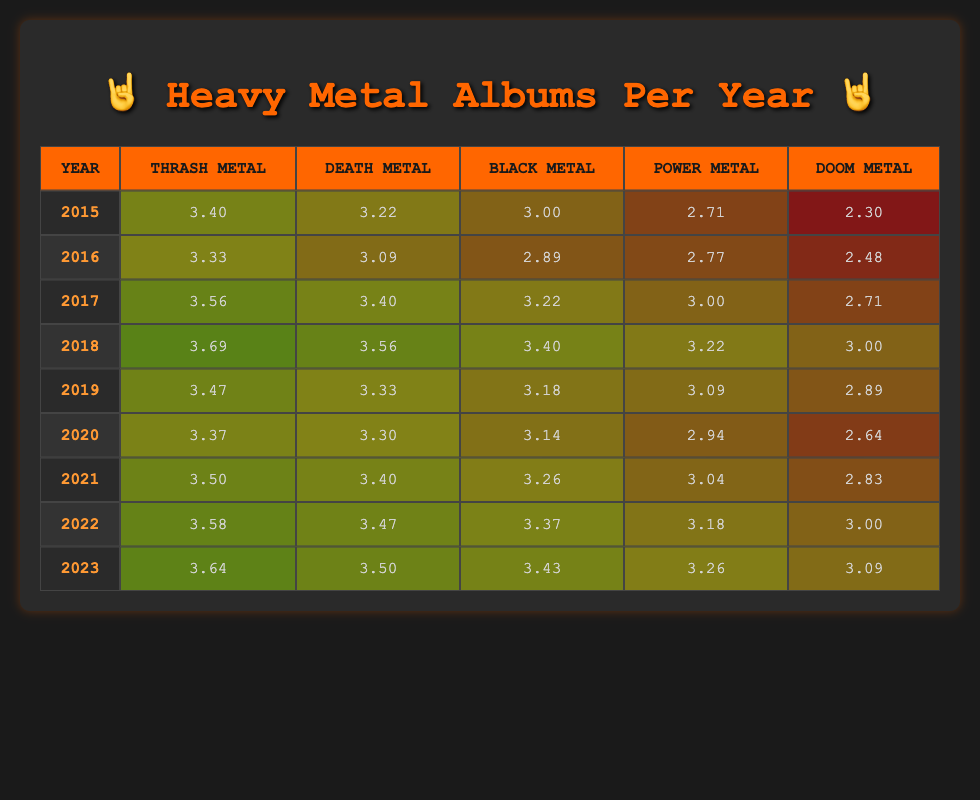What was the total number of thrash metal albums released from 2015 to 2023? To find the total number of thrash metal albums, we add the values from each year: 30 + 28 + 35 + 40 + 32 + 29 + 33 + 36 + 38 =  329
Answer: 329 In what year was the highest number of doom metal albums released? Looking at the doom metal column for all the years, the highest value is 22 in the year 2023.
Answer: 2023 What is the average number of black metal albums released per year from 2015 to 2023? We sum the black metal albums for each year: 20 + 18 + 25 + 30 + 24 + 23 + 26 + 29 + 31 =  226. There are 9 years, so we divide: 226 / 9 = 25.11 (rounded to two decimal places).
Answer: 25.11 Did the number of death metal albums released increase every year from 2015 to 2018? Checking the values for death metal from 2015 to 2018: 25 (2015), 22 (2016), 30 (2017), 35 (2018). The values do not consistently increase; specifically, it decreased from 2015 to 2016.
Answer: No Which genre saw the largest increase in album releases from 2019 to 2020? We calculate the difference for each genre between 2019 and 2020: Thrash: 29 - 32 = -3, Death: 27 - 28 = -1, Black: 23 - 24 = -1, Power: 19 - 22 = -3, Doom: 14 - 18 = -4. Doom metal had the largest decrease of -4, meaning it had the largest increase backwards.
Answer: Doom Metal In which year was the second-highest number of power metal albums released? Power metal albums by year: 15 (2015), 16 (2016), 20 (2017), 25 (2018), 22 (2019), 19 (2020), 21 (2021), 24 (2022), 26 (2023). The highest (26 in 2023) and second highest (25 in 2018).
Answer: 2018 